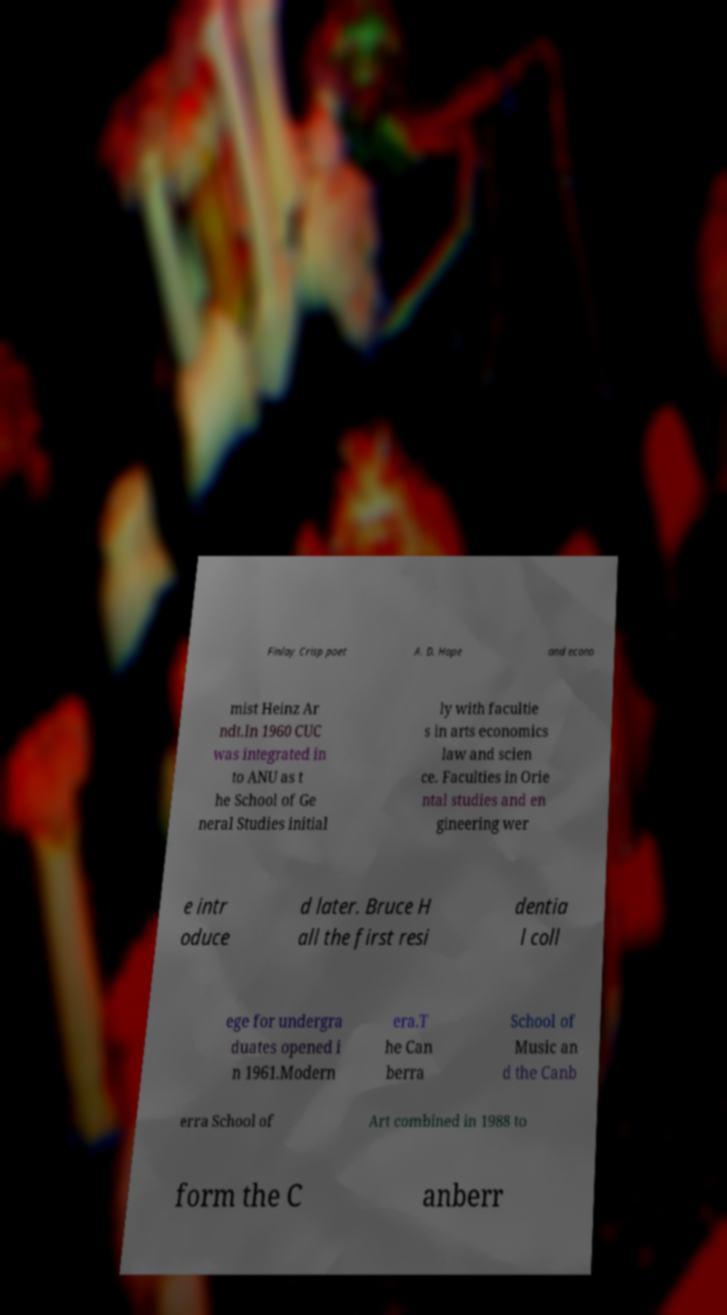Please identify and transcribe the text found in this image. Finlay Crisp poet A. D. Hope and econo mist Heinz Ar ndt.In 1960 CUC was integrated in to ANU as t he School of Ge neral Studies initial ly with facultie s in arts economics law and scien ce. Faculties in Orie ntal studies and en gineering wer e intr oduce d later. Bruce H all the first resi dentia l coll ege for undergra duates opened i n 1961.Modern era.T he Can berra School of Music an d the Canb erra School of Art combined in 1988 to form the C anberr 